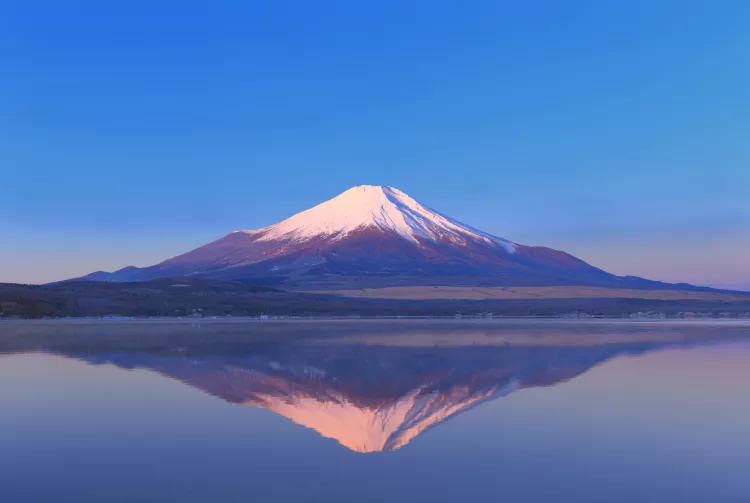Can you describe the influence of natural elements on the scenery in this image? The scenery in this image is significantly influenced by natural elements such as light, water, and air. The calm weather conditions allow the water to remain undisturbed, creating a perfect mirror-like surface that reflects the mountain. The clear skies contribute to the vibrant colors at sunrise, enhancing the visual contrast and depth. Additionally, the air's clarity helps in the sharp depiction of the mountain and its textures, foregrounding its grandeur in the natural landscape. 